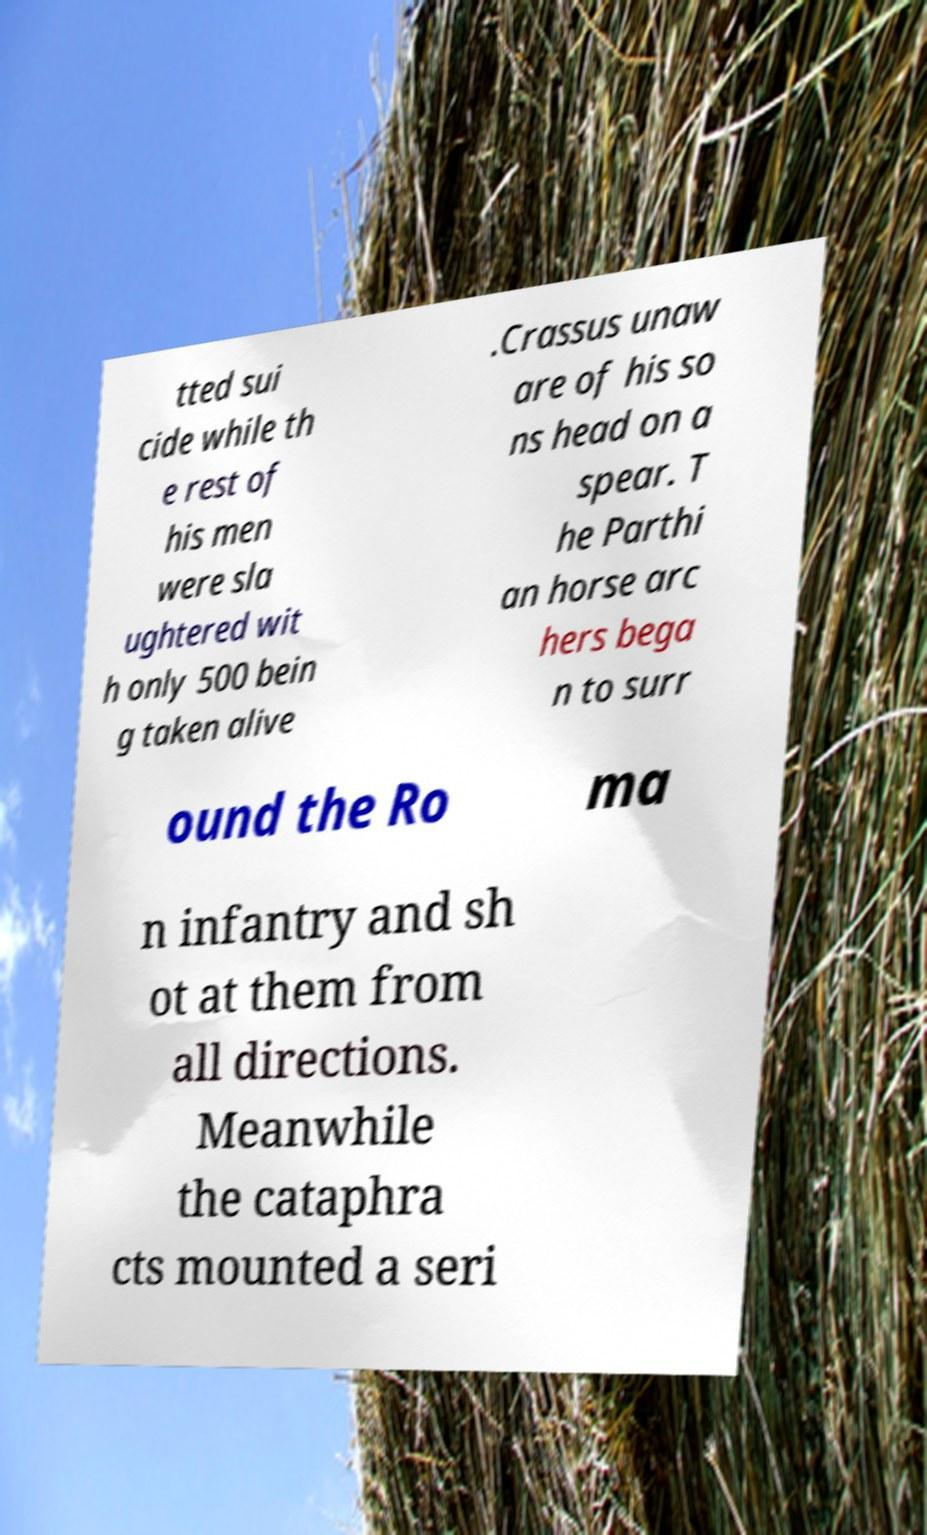For documentation purposes, I need the text within this image transcribed. Could you provide that? tted sui cide while th e rest of his men were sla ughtered wit h only 500 bein g taken alive .Crassus unaw are of his so ns head on a spear. T he Parthi an horse arc hers bega n to surr ound the Ro ma n infantry and sh ot at them from all directions. Meanwhile the cataphra cts mounted a seri 